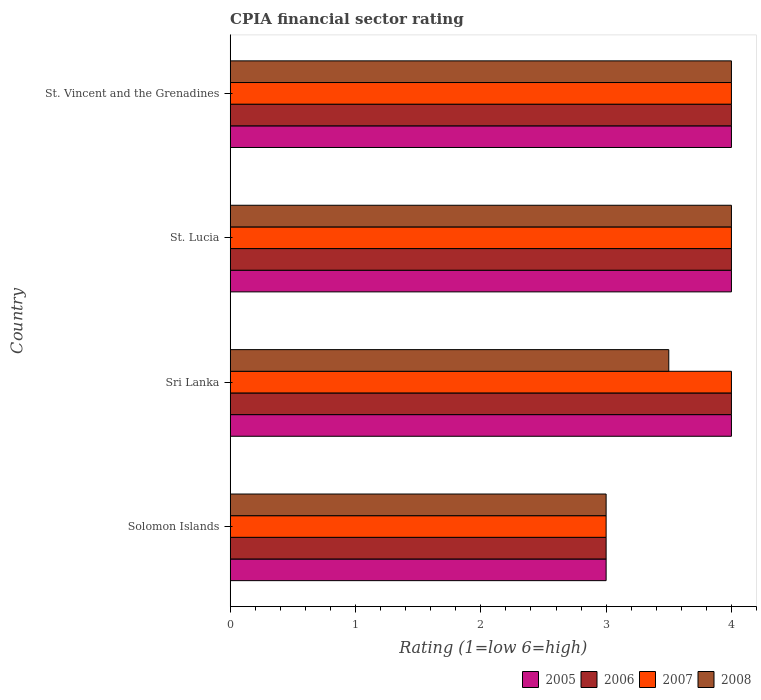Are the number of bars per tick equal to the number of legend labels?
Offer a terse response. Yes. How many bars are there on the 4th tick from the top?
Offer a terse response. 4. What is the label of the 3rd group of bars from the top?
Your response must be concise. Sri Lanka. In how many cases, is the number of bars for a given country not equal to the number of legend labels?
Keep it short and to the point. 0. Across all countries, what is the minimum CPIA rating in 2005?
Keep it short and to the point. 3. In which country was the CPIA rating in 2005 maximum?
Offer a terse response. Sri Lanka. In which country was the CPIA rating in 2007 minimum?
Provide a succinct answer. Solomon Islands. What is the total CPIA rating in 2006 in the graph?
Keep it short and to the point. 15. What is the difference between the CPIA rating in 2007 in Solomon Islands and that in St. Lucia?
Keep it short and to the point. -1. What is the difference between the CPIA rating in 2006 in St. Vincent and the Grenadines and the CPIA rating in 2005 in Sri Lanka?
Ensure brevity in your answer.  0. What is the average CPIA rating in 2005 per country?
Keep it short and to the point. 3.75. What is the difference between the CPIA rating in 2005 and CPIA rating in 2007 in St. Vincent and the Grenadines?
Give a very brief answer. 0. Is the difference between the CPIA rating in 2005 in Solomon Islands and Sri Lanka greater than the difference between the CPIA rating in 2007 in Solomon Islands and Sri Lanka?
Offer a terse response. No. What is the difference between the highest and the second highest CPIA rating in 2006?
Make the answer very short. 0. Is it the case that in every country, the sum of the CPIA rating in 2007 and CPIA rating in 2008 is greater than the sum of CPIA rating in 2005 and CPIA rating in 2006?
Provide a short and direct response. No. Is it the case that in every country, the sum of the CPIA rating in 2005 and CPIA rating in 2008 is greater than the CPIA rating in 2006?
Offer a very short reply. Yes. How many countries are there in the graph?
Keep it short and to the point. 4. Does the graph contain any zero values?
Your response must be concise. No. Where does the legend appear in the graph?
Your answer should be compact. Bottom right. How are the legend labels stacked?
Keep it short and to the point. Horizontal. What is the title of the graph?
Provide a succinct answer. CPIA financial sector rating. What is the label or title of the Y-axis?
Offer a very short reply. Country. What is the Rating (1=low 6=high) of 2005 in Solomon Islands?
Your response must be concise. 3. What is the Rating (1=low 6=high) of 2007 in Solomon Islands?
Your response must be concise. 3. What is the Rating (1=low 6=high) in 2005 in Sri Lanka?
Your answer should be compact. 4. What is the Rating (1=low 6=high) of 2006 in Sri Lanka?
Your response must be concise. 4. What is the Rating (1=low 6=high) of 2005 in St. Lucia?
Provide a succinct answer. 4. What is the Rating (1=low 6=high) of 2005 in St. Vincent and the Grenadines?
Make the answer very short. 4. Across all countries, what is the maximum Rating (1=low 6=high) of 2005?
Make the answer very short. 4. Across all countries, what is the maximum Rating (1=low 6=high) in 2007?
Provide a short and direct response. 4. Across all countries, what is the maximum Rating (1=low 6=high) in 2008?
Provide a succinct answer. 4. Across all countries, what is the minimum Rating (1=low 6=high) of 2007?
Provide a succinct answer. 3. Across all countries, what is the minimum Rating (1=low 6=high) of 2008?
Make the answer very short. 3. What is the total Rating (1=low 6=high) of 2005 in the graph?
Make the answer very short. 15. What is the total Rating (1=low 6=high) of 2007 in the graph?
Provide a short and direct response. 15. What is the total Rating (1=low 6=high) of 2008 in the graph?
Offer a very short reply. 14.5. What is the difference between the Rating (1=low 6=high) of 2005 in Solomon Islands and that in Sri Lanka?
Offer a very short reply. -1. What is the difference between the Rating (1=low 6=high) of 2006 in Solomon Islands and that in Sri Lanka?
Make the answer very short. -1. What is the difference between the Rating (1=low 6=high) in 2008 in Solomon Islands and that in Sri Lanka?
Your response must be concise. -0.5. What is the difference between the Rating (1=low 6=high) in 2005 in Solomon Islands and that in St. Lucia?
Your response must be concise. -1. What is the difference between the Rating (1=low 6=high) of 2006 in Solomon Islands and that in St. Lucia?
Give a very brief answer. -1. What is the difference between the Rating (1=low 6=high) in 2006 in Solomon Islands and that in St. Vincent and the Grenadines?
Make the answer very short. -1. What is the difference between the Rating (1=low 6=high) in 2007 in Solomon Islands and that in St. Vincent and the Grenadines?
Make the answer very short. -1. What is the difference between the Rating (1=low 6=high) in 2008 in Solomon Islands and that in St. Vincent and the Grenadines?
Your answer should be compact. -1. What is the difference between the Rating (1=low 6=high) of 2005 in Sri Lanka and that in St. Vincent and the Grenadines?
Provide a short and direct response. 0. What is the difference between the Rating (1=low 6=high) of 2006 in Sri Lanka and that in St. Vincent and the Grenadines?
Keep it short and to the point. 0. What is the difference between the Rating (1=low 6=high) of 2005 in St. Lucia and that in St. Vincent and the Grenadines?
Provide a succinct answer. 0. What is the difference between the Rating (1=low 6=high) of 2006 in St. Lucia and that in St. Vincent and the Grenadines?
Your response must be concise. 0. What is the difference between the Rating (1=low 6=high) of 2007 in St. Lucia and that in St. Vincent and the Grenadines?
Offer a terse response. 0. What is the difference between the Rating (1=low 6=high) of 2005 in Solomon Islands and the Rating (1=low 6=high) of 2006 in Sri Lanka?
Keep it short and to the point. -1. What is the difference between the Rating (1=low 6=high) in 2005 in Solomon Islands and the Rating (1=low 6=high) in 2008 in Sri Lanka?
Provide a short and direct response. -0.5. What is the difference between the Rating (1=low 6=high) of 2006 in Solomon Islands and the Rating (1=low 6=high) of 2007 in Sri Lanka?
Offer a terse response. -1. What is the difference between the Rating (1=low 6=high) of 2007 in Solomon Islands and the Rating (1=low 6=high) of 2008 in Sri Lanka?
Give a very brief answer. -0.5. What is the difference between the Rating (1=low 6=high) in 2007 in Solomon Islands and the Rating (1=low 6=high) in 2008 in St. Lucia?
Give a very brief answer. -1. What is the difference between the Rating (1=low 6=high) of 2005 in Solomon Islands and the Rating (1=low 6=high) of 2006 in St. Vincent and the Grenadines?
Offer a very short reply. -1. What is the difference between the Rating (1=low 6=high) of 2005 in Solomon Islands and the Rating (1=low 6=high) of 2007 in St. Vincent and the Grenadines?
Your response must be concise. -1. What is the difference between the Rating (1=low 6=high) in 2006 in Solomon Islands and the Rating (1=low 6=high) in 2007 in St. Vincent and the Grenadines?
Keep it short and to the point. -1. What is the difference between the Rating (1=low 6=high) in 2006 in Solomon Islands and the Rating (1=low 6=high) in 2008 in St. Vincent and the Grenadines?
Offer a very short reply. -1. What is the difference between the Rating (1=low 6=high) of 2005 in Sri Lanka and the Rating (1=low 6=high) of 2006 in St. Lucia?
Ensure brevity in your answer.  0. What is the difference between the Rating (1=low 6=high) in 2005 in Sri Lanka and the Rating (1=low 6=high) in 2007 in St. Lucia?
Provide a short and direct response. 0. What is the difference between the Rating (1=low 6=high) in 2005 in Sri Lanka and the Rating (1=low 6=high) in 2008 in St. Lucia?
Your response must be concise. 0. What is the difference between the Rating (1=low 6=high) in 2006 in Sri Lanka and the Rating (1=low 6=high) in 2007 in St. Lucia?
Ensure brevity in your answer.  0. What is the difference between the Rating (1=low 6=high) in 2006 in Sri Lanka and the Rating (1=low 6=high) in 2008 in St. Lucia?
Keep it short and to the point. 0. What is the difference between the Rating (1=low 6=high) in 2007 in Sri Lanka and the Rating (1=low 6=high) in 2008 in St. Lucia?
Give a very brief answer. 0. What is the difference between the Rating (1=low 6=high) of 2005 in Sri Lanka and the Rating (1=low 6=high) of 2008 in St. Vincent and the Grenadines?
Your answer should be compact. 0. What is the difference between the Rating (1=low 6=high) in 2005 in St. Lucia and the Rating (1=low 6=high) in 2006 in St. Vincent and the Grenadines?
Keep it short and to the point. 0. What is the difference between the Rating (1=low 6=high) of 2007 in St. Lucia and the Rating (1=low 6=high) of 2008 in St. Vincent and the Grenadines?
Provide a short and direct response. 0. What is the average Rating (1=low 6=high) in 2005 per country?
Ensure brevity in your answer.  3.75. What is the average Rating (1=low 6=high) in 2006 per country?
Offer a very short reply. 3.75. What is the average Rating (1=low 6=high) in 2007 per country?
Provide a succinct answer. 3.75. What is the average Rating (1=low 6=high) in 2008 per country?
Ensure brevity in your answer.  3.62. What is the difference between the Rating (1=low 6=high) in 2005 and Rating (1=low 6=high) in 2006 in Solomon Islands?
Provide a short and direct response. 0. What is the difference between the Rating (1=low 6=high) of 2005 and Rating (1=low 6=high) of 2007 in Solomon Islands?
Provide a succinct answer. 0. What is the difference between the Rating (1=low 6=high) in 2005 and Rating (1=low 6=high) in 2008 in Solomon Islands?
Your response must be concise. 0. What is the difference between the Rating (1=low 6=high) in 2007 and Rating (1=low 6=high) in 2008 in Solomon Islands?
Offer a very short reply. 0. What is the difference between the Rating (1=low 6=high) in 2005 and Rating (1=low 6=high) in 2006 in Sri Lanka?
Provide a short and direct response. 0. What is the difference between the Rating (1=low 6=high) of 2005 and Rating (1=low 6=high) of 2006 in St. Lucia?
Provide a succinct answer. 0. What is the difference between the Rating (1=low 6=high) in 2005 and Rating (1=low 6=high) in 2007 in St. Lucia?
Provide a short and direct response. 0. What is the difference between the Rating (1=low 6=high) of 2006 and Rating (1=low 6=high) of 2008 in St. Lucia?
Ensure brevity in your answer.  0. What is the difference between the Rating (1=low 6=high) in 2007 and Rating (1=low 6=high) in 2008 in St. Lucia?
Offer a terse response. 0. What is the difference between the Rating (1=low 6=high) of 2005 and Rating (1=low 6=high) of 2006 in St. Vincent and the Grenadines?
Offer a terse response. 0. What is the difference between the Rating (1=low 6=high) of 2006 and Rating (1=low 6=high) of 2007 in St. Vincent and the Grenadines?
Keep it short and to the point. 0. What is the difference between the Rating (1=low 6=high) in 2006 and Rating (1=low 6=high) in 2008 in St. Vincent and the Grenadines?
Ensure brevity in your answer.  0. What is the difference between the Rating (1=low 6=high) of 2007 and Rating (1=low 6=high) of 2008 in St. Vincent and the Grenadines?
Your response must be concise. 0. What is the ratio of the Rating (1=low 6=high) in 2007 in Solomon Islands to that in Sri Lanka?
Offer a terse response. 0.75. What is the ratio of the Rating (1=low 6=high) of 2005 in Solomon Islands to that in St. Lucia?
Offer a very short reply. 0.75. What is the ratio of the Rating (1=low 6=high) of 2006 in Solomon Islands to that in St. Lucia?
Your answer should be compact. 0.75. What is the ratio of the Rating (1=low 6=high) in 2007 in Solomon Islands to that in St. Lucia?
Give a very brief answer. 0.75. What is the ratio of the Rating (1=low 6=high) in 2005 in Sri Lanka to that in St. Lucia?
Offer a very short reply. 1. What is the ratio of the Rating (1=low 6=high) of 2005 in Sri Lanka to that in St. Vincent and the Grenadines?
Provide a succinct answer. 1. What is the ratio of the Rating (1=low 6=high) in 2006 in Sri Lanka to that in St. Vincent and the Grenadines?
Give a very brief answer. 1. What is the ratio of the Rating (1=low 6=high) of 2007 in Sri Lanka to that in St. Vincent and the Grenadines?
Give a very brief answer. 1. What is the ratio of the Rating (1=low 6=high) in 2008 in Sri Lanka to that in St. Vincent and the Grenadines?
Make the answer very short. 0.88. What is the ratio of the Rating (1=low 6=high) in 2005 in St. Lucia to that in St. Vincent and the Grenadines?
Your answer should be very brief. 1. What is the ratio of the Rating (1=low 6=high) in 2006 in St. Lucia to that in St. Vincent and the Grenadines?
Keep it short and to the point. 1. What is the ratio of the Rating (1=low 6=high) in 2008 in St. Lucia to that in St. Vincent and the Grenadines?
Offer a very short reply. 1. What is the difference between the highest and the second highest Rating (1=low 6=high) of 2005?
Your response must be concise. 0. What is the difference between the highest and the second highest Rating (1=low 6=high) of 2006?
Provide a short and direct response. 0. What is the difference between the highest and the second highest Rating (1=low 6=high) in 2007?
Your answer should be compact. 0. What is the difference between the highest and the lowest Rating (1=low 6=high) of 2006?
Your answer should be compact. 1. What is the difference between the highest and the lowest Rating (1=low 6=high) of 2007?
Give a very brief answer. 1. What is the difference between the highest and the lowest Rating (1=low 6=high) of 2008?
Offer a terse response. 1. 